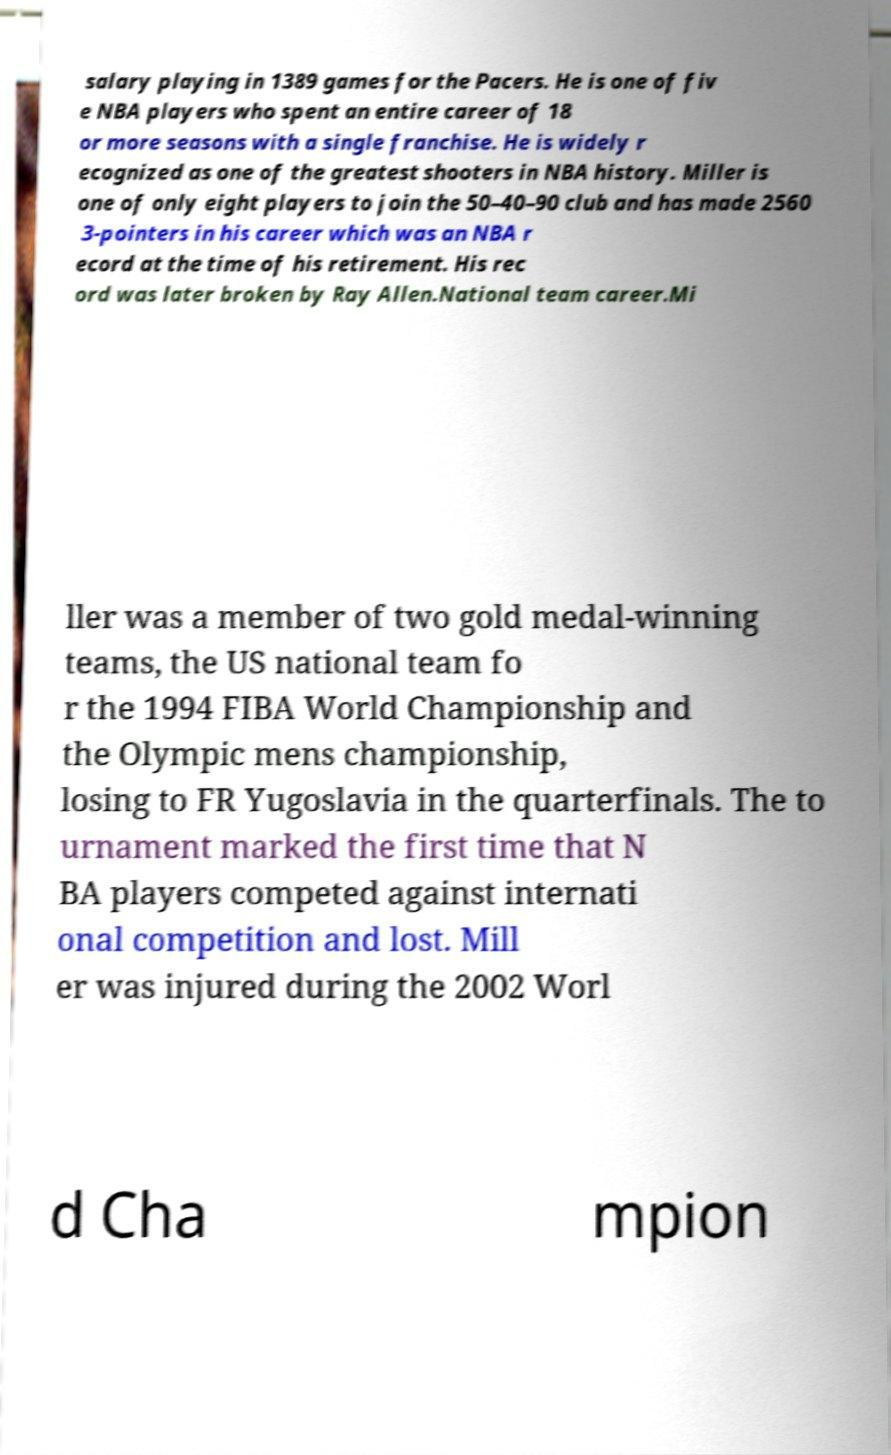What messages or text are displayed in this image? I need them in a readable, typed format. salary playing in 1389 games for the Pacers. He is one of fiv e NBA players who spent an entire career of 18 or more seasons with a single franchise. He is widely r ecognized as one of the greatest shooters in NBA history. Miller is one of only eight players to join the 50–40–90 club and has made 2560 3-pointers in his career which was an NBA r ecord at the time of his retirement. His rec ord was later broken by Ray Allen.National team career.Mi ller was a member of two gold medal-winning teams, the US national team fo r the 1994 FIBA World Championship and the Olympic mens championship, losing to FR Yugoslavia in the quarterfinals. The to urnament marked the first time that N BA players competed against internati onal competition and lost. Mill er was injured during the 2002 Worl d Cha mpion 